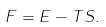<formula> <loc_0><loc_0><loc_500><loc_500>F = E - T S .</formula> 